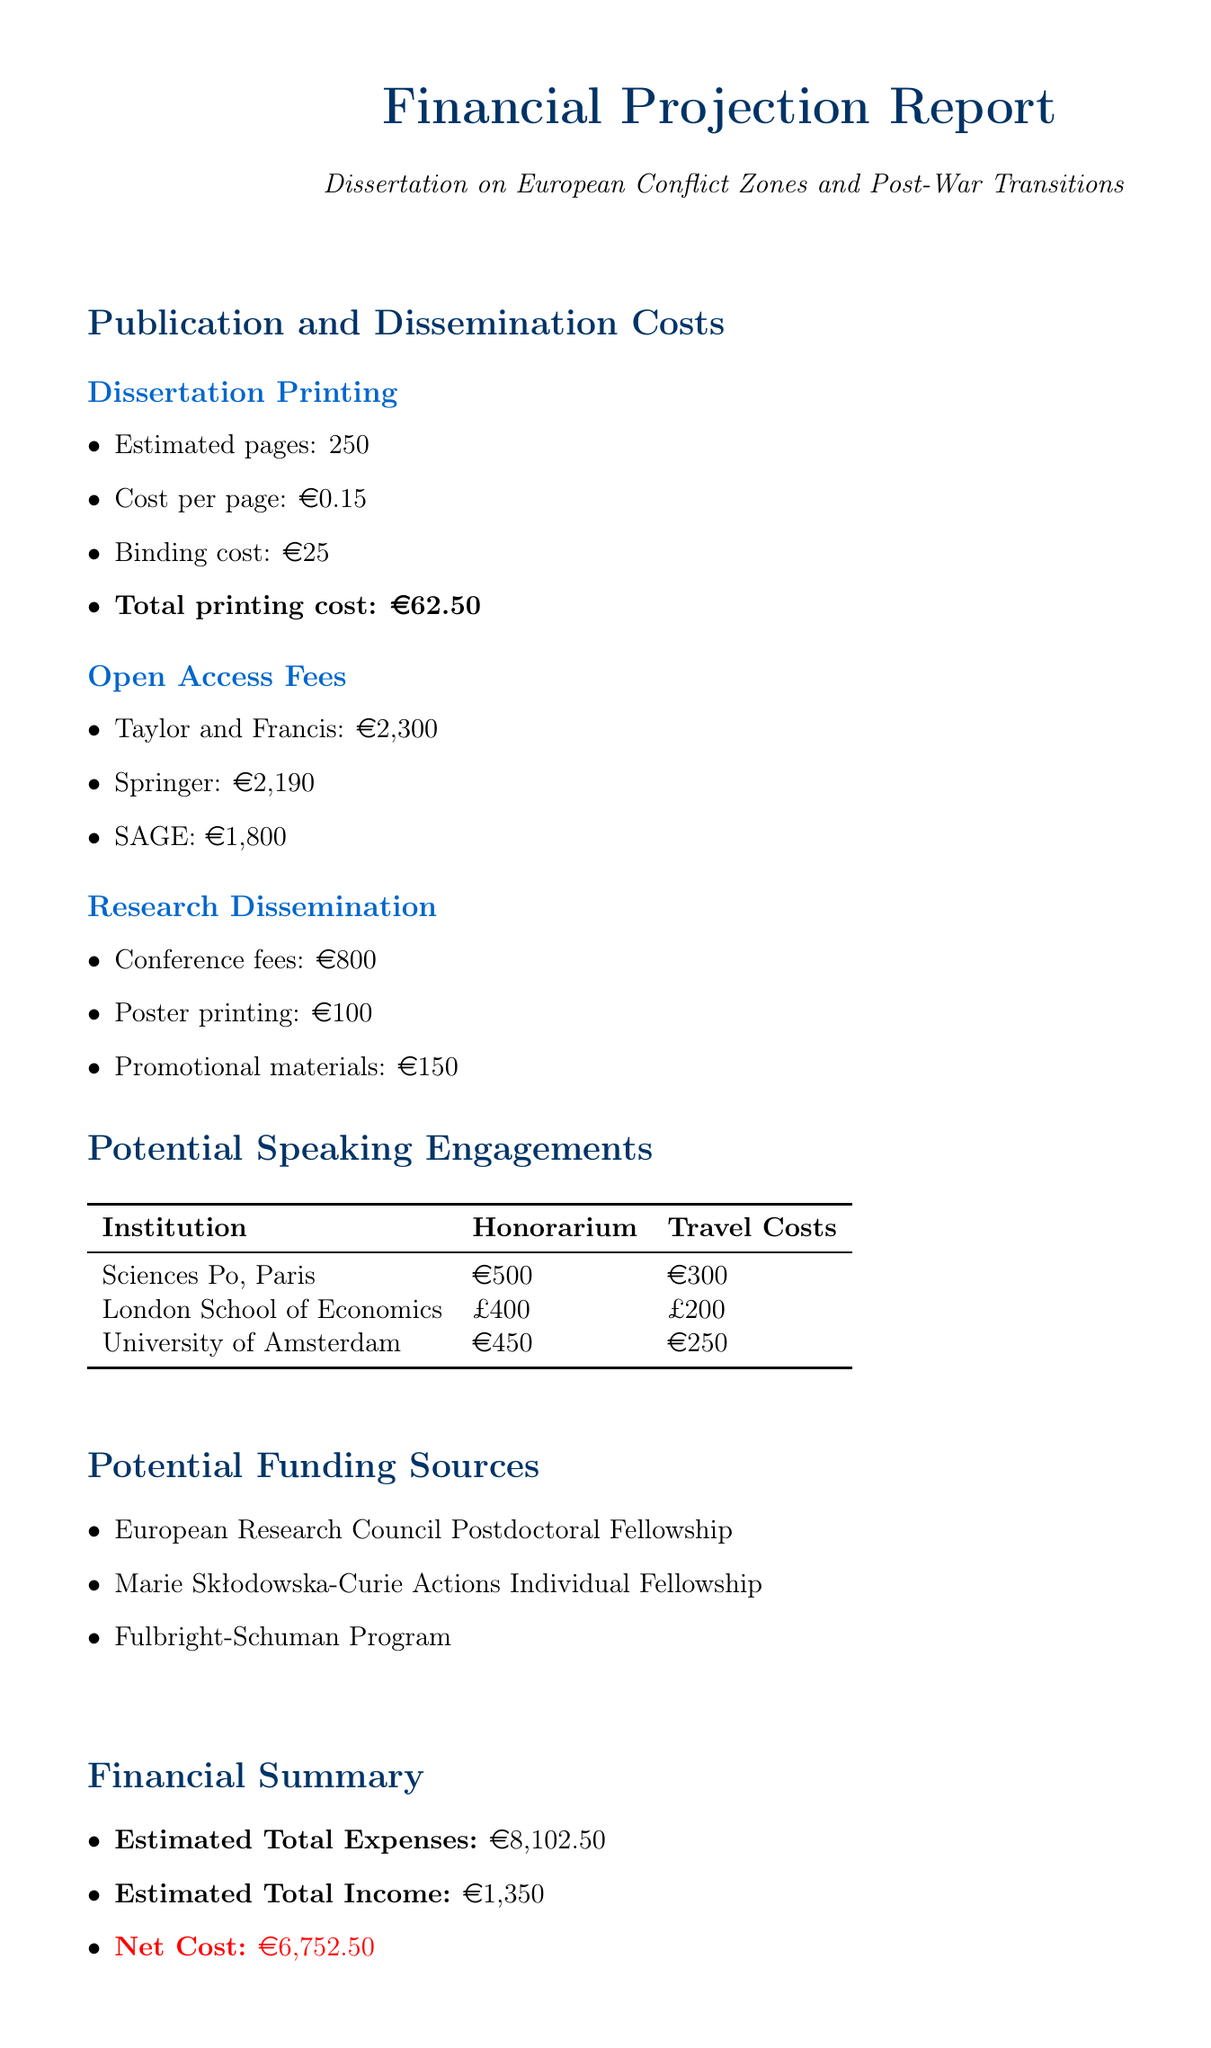what is the total printing cost? The total printing cost is calculated from the estimated pages, cost per page, and binding cost, yielding €62.50.
Answer: €62.50 which institution offers an honorarium of €500? The document states that Sciences Po in Paris offers an honorarium of €500.
Answer: Sciences Po, Paris what are the open access fees for Springer? The document lists the open access fee for Springer as €2,190.
Answer: €2,190 what is the estimated total income? The estimated total income is provided as €1,350 in the financial summary.
Answer: €1,350 how much are the travel costs for the University of Amsterdam engagement? The travel costs for the University of Amsterdam are stated as €250.
Answer: €250 how much will you incur in total expenses? The document summarizes the total expenses as €8,102.50.
Answer: €8,102.50 which funding source is mentioned first in the list? The first funding source mentioned is the European Research Council Postdoctoral Fellowship.
Answer: European Research Council Postdoctoral Fellowship what is the total cost of promotional materials? The document specifies the cost of promotional materials as €150.
Answer: €150 what is the net cost after estimated income? The net cost is calculated subtracting the estimated total income from the estimated total expenses, leading to €6,752.50.
Answer: €6,752.50 